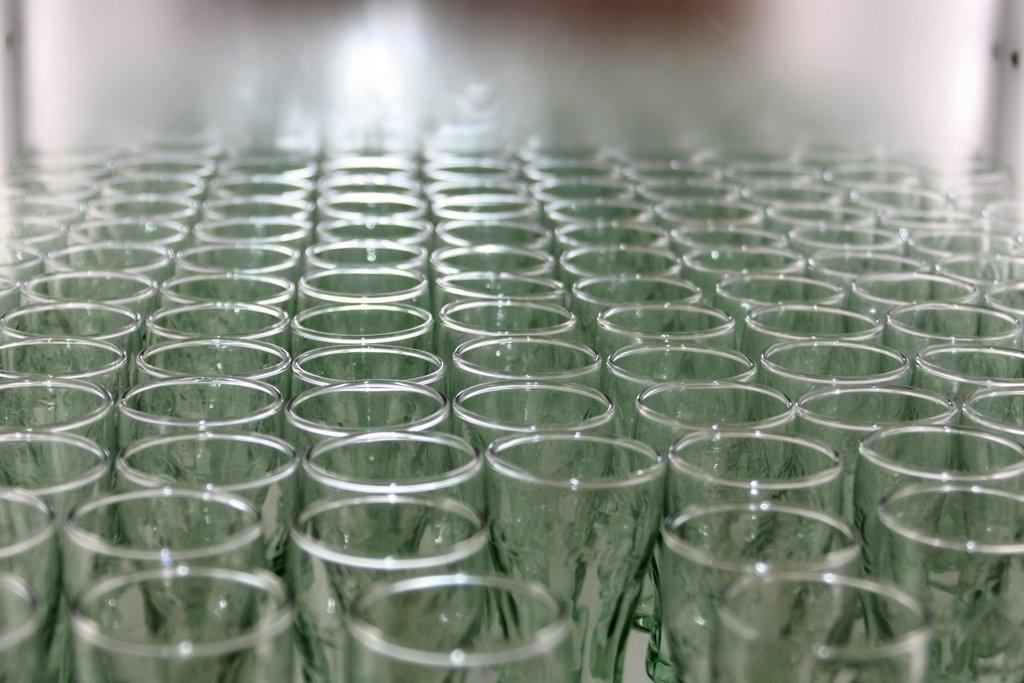What objects are present in the image? There are glasses in the image. Can you describe the glasses in more detail? Unfortunately, the provided facts do not offer any additional details about the glasses. Are there any other objects or people visible in the image? The given facts do not mention any other objects or people in the image. What type of fan is visible in the image? There is no fan present in the image; only glasses are mentioned. 